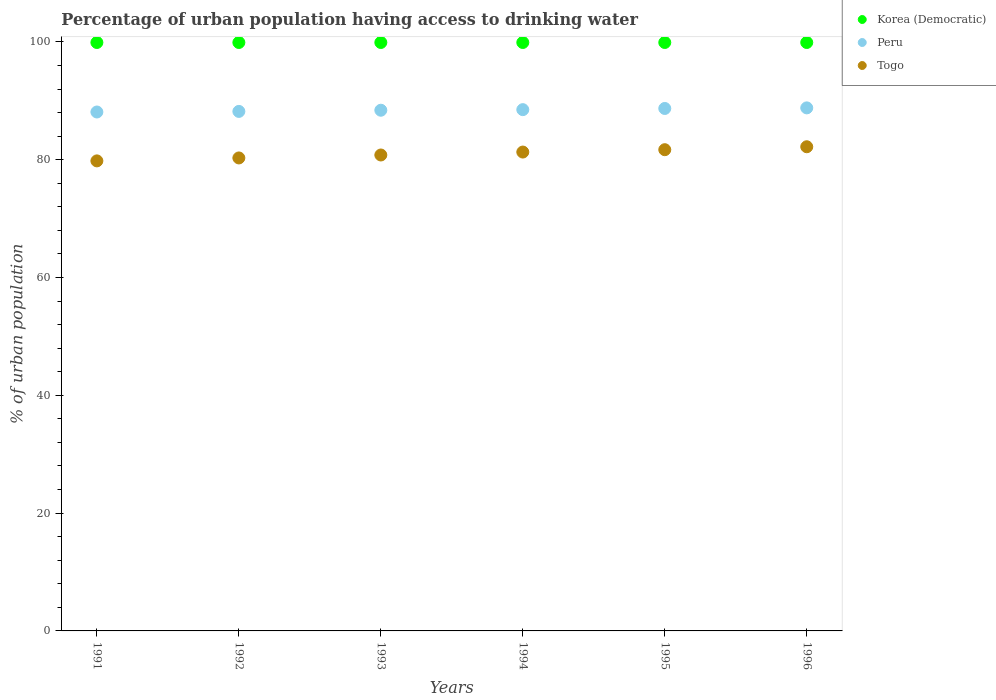Is the number of dotlines equal to the number of legend labels?
Make the answer very short. Yes. What is the percentage of urban population having access to drinking water in Peru in 1993?
Ensure brevity in your answer.  88.4. Across all years, what is the maximum percentage of urban population having access to drinking water in Peru?
Make the answer very short. 88.8. Across all years, what is the minimum percentage of urban population having access to drinking water in Peru?
Offer a very short reply. 88.1. In which year was the percentage of urban population having access to drinking water in Peru maximum?
Offer a terse response. 1996. In which year was the percentage of urban population having access to drinking water in Korea (Democratic) minimum?
Keep it short and to the point. 1991. What is the total percentage of urban population having access to drinking water in Peru in the graph?
Your response must be concise. 530.7. What is the difference between the percentage of urban population having access to drinking water in Togo in 1992 and that in 1995?
Your answer should be compact. -1.4. What is the difference between the percentage of urban population having access to drinking water in Peru in 1993 and the percentage of urban population having access to drinking water in Korea (Democratic) in 1992?
Provide a succinct answer. -11.5. What is the average percentage of urban population having access to drinking water in Korea (Democratic) per year?
Provide a succinct answer. 99.9. In the year 1993, what is the difference between the percentage of urban population having access to drinking water in Peru and percentage of urban population having access to drinking water in Togo?
Your answer should be very brief. 7.6. In how many years, is the percentage of urban population having access to drinking water in Korea (Democratic) greater than 92 %?
Offer a very short reply. 6. What is the ratio of the percentage of urban population having access to drinking water in Togo in 1991 to that in 1996?
Keep it short and to the point. 0.97. Is the percentage of urban population having access to drinking water in Togo in 1991 less than that in 1996?
Provide a succinct answer. Yes. What is the difference between the highest and the second highest percentage of urban population having access to drinking water in Peru?
Provide a succinct answer. 0.1. In how many years, is the percentage of urban population having access to drinking water in Peru greater than the average percentage of urban population having access to drinking water in Peru taken over all years?
Provide a short and direct response. 3. Is the sum of the percentage of urban population having access to drinking water in Korea (Democratic) in 1994 and 1996 greater than the maximum percentage of urban population having access to drinking water in Togo across all years?
Your answer should be very brief. Yes. Is it the case that in every year, the sum of the percentage of urban population having access to drinking water in Togo and percentage of urban population having access to drinking water in Korea (Democratic)  is greater than the percentage of urban population having access to drinking water in Peru?
Keep it short and to the point. Yes. Is the percentage of urban population having access to drinking water in Togo strictly greater than the percentage of urban population having access to drinking water in Korea (Democratic) over the years?
Provide a short and direct response. No. Is the percentage of urban population having access to drinking water in Korea (Democratic) strictly less than the percentage of urban population having access to drinking water in Togo over the years?
Ensure brevity in your answer.  No. How many dotlines are there?
Your answer should be very brief. 3. What is the difference between two consecutive major ticks on the Y-axis?
Make the answer very short. 20. Are the values on the major ticks of Y-axis written in scientific E-notation?
Keep it short and to the point. No. Does the graph contain any zero values?
Make the answer very short. No. Where does the legend appear in the graph?
Offer a terse response. Top right. How are the legend labels stacked?
Ensure brevity in your answer.  Vertical. What is the title of the graph?
Offer a very short reply. Percentage of urban population having access to drinking water. Does "St. Kitts and Nevis" appear as one of the legend labels in the graph?
Offer a very short reply. No. What is the label or title of the Y-axis?
Offer a very short reply. % of urban population. What is the % of urban population of Korea (Democratic) in 1991?
Provide a succinct answer. 99.9. What is the % of urban population in Peru in 1991?
Offer a terse response. 88.1. What is the % of urban population in Togo in 1991?
Provide a short and direct response. 79.8. What is the % of urban population of Korea (Democratic) in 1992?
Provide a succinct answer. 99.9. What is the % of urban population of Peru in 1992?
Keep it short and to the point. 88.2. What is the % of urban population of Togo in 1992?
Provide a short and direct response. 80.3. What is the % of urban population of Korea (Democratic) in 1993?
Provide a succinct answer. 99.9. What is the % of urban population of Peru in 1993?
Provide a short and direct response. 88.4. What is the % of urban population in Togo in 1993?
Offer a terse response. 80.8. What is the % of urban population in Korea (Democratic) in 1994?
Keep it short and to the point. 99.9. What is the % of urban population of Peru in 1994?
Your answer should be compact. 88.5. What is the % of urban population in Togo in 1994?
Your answer should be compact. 81.3. What is the % of urban population of Korea (Democratic) in 1995?
Ensure brevity in your answer.  99.9. What is the % of urban population in Peru in 1995?
Provide a succinct answer. 88.7. What is the % of urban population of Togo in 1995?
Give a very brief answer. 81.7. What is the % of urban population of Korea (Democratic) in 1996?
Provide a succinct answer. 99.9. What is the % of urban population in Peru in 1996?
Provide a short and direct response. 88.8. What is the % of urban population of Togo in 1996?
Make the answer very short. 82.2. Across all years, what is the maximum % of urban population in Korea (Democratic)?
Give a very brief answer. 99.9. Across all years, what is the maximum % of urban population of Peru?
Keep it short and to the point. 88.8. Across all years, what is the maximum % of urban population in Togo?
Give a very brief answer. 82.2. Across all years, what is the minimum % of urban population of Korea (Democratic)?
Your response must be concise. 99.9. Across all years, what is the minimum % of urban population of Peru?
Provide a succinct answer. 88.1. Across all years, what is the minimum % of urban population of Togo?
Give a very brief answer. 79.8. What is the total % of urban population in Korea (Democratic) in the graph?
Ensure brevity in your answer.  599.4. What is the total % of urban population in Peru in the graph?
Your answer should be compact. 530.7. What is the total % of urban population of Togo in the graph?
Your response must be concise. 486.1. What is the difference between the % of urban population in Togo in 1991 and that in 1992?
Your response must be concise. -0.5. What is the difference between the % of urban population in Korea (Democratic) in 1991 and that in 1993?
Provide a succinct answer. 0. What is the difference between the % of urban population in Korea (Democratic) in 1991 and that in 1994?
Provide a succinct answer. 0. What is the difference between the % of urban population in Peru in 1991 and that in 1994?
Your answer should be very brief. -0.4. What is the difference between the % of urban population of Peru in 1991 and that in 1995?
Offer a very short reply. -0.6. What is the difference between the % of urban population in Korea (Democratic) in 1991 and that in 1996?
Offer a terse response. 0. What is the difference between the % of urban population of Peru in 1991 and that in 1996?
Offer a very short reply. -0.7. What is the difference between the % of urban population in Togo in 1991 and that in 1996?
Your answer should be compact. -2.4. What is the difference between the % of urban population in Peru in 1992 and that in 1993?
Make the answer very short. -0.2. What is the difference between the % of urban population in Togo in 1992 and that in 1993?
Give a very brief answer. -0.5. What is the difference between the % of urban population in Korea (Democratic) in 1992 and that in 1994?
Ensure brevity in your answer.  0. What is the difference between the % of urban population of Korea (Democratic) in 1992 and that in 1995?
Offer a very short reply. 0. What is the difference between the % of urban population in Peru in 1992 and that in 1995?
Your answer should be very brief. -0.5. What is the difference between the % of urban population in Togo in 1992 and that in 1995?
Ensure brevity in your answer.  -1.4. What is the difference between the % of urban population of Peru in 1992 and that in 1996?
Your answer should be compact. -0.6. What is the difference between the % of urban population in Togo in 1992 and that in 1996?
Your answer should be very brief. -1.9. What is the difference between the % of urban population in Togo in 1993 and that in 1994?
Offer a terse response. -0.5. What is the difference between the % of urban population in Korea (Democratic) in 1993 and that in 1995?
Your answer should be compact. 0. What is the difference between the % of urban population of Togo in 1993 and that in 1995?
Your response must be concise. -0.9. What is the difference between the % of urban population of Korea (Democratic) in 1994 and that in 1995?
Keep it short and to the point. 0. What is the difference between the % of urban population in Togo in 1994 and that in 1995?
Ensure brevity in your answer.  -0.4. What is the difference between the % of urban population of Korea (Democratic) in 1994 and that in 1996?
Make the answer very short. 0. What is the difference between the % of urban population in Peru in 1994 and that in 1996?
Offer a very short reply. -0.3. What is the difference between the % of urban population of Korea (Democratic) in 1995 and that in 1996?
Offer a very short reply. 0. What is the difference between the % of urban population in Togo in 1995 and that in 1996?
Your response must be concise. -0.5. What is the difference between the % of urban population in Korea (Democratic) in 1991 and the % of urban population in Togo in 1992?
Your answer should be very brief. 19.6. What is the difference between the % of urban population of Peru in 1991 and the % of urban population of Togo in 1992?
Provide a succinct answer. 7.8. What is the difference between the % of urban population in Korea (Democratic) in 1991 and the % of urban population in Togo in 1993?
Your response must be concise. 19.1. What is the difference between the % of urban population of Korea (Democratic) in 1991 and the % of urban population of Togo in 1994?
Your answer should be very brief. 18.6. What is the difference between the % of urban population in Korea (Democratic) in 1991 and the % of urban population in Peru in 1995?
Offer a terse response. 11.2. What is the difference between the % of urban population in Korea (Democratic) in 1991 and the % of urban population in Peru in 1996?
Make the answer very short. 11.1. What is the difference between the % of urban population of Peru in 1991 and the % of urban population of Togo in 1996?
Ensure brevity in your answer.  5.9. What is the difference between the % of urban population in Korea (Democratic) in 1992 and the % of urban population in Togo in 1994?
Keep it short and to the point. 18.6. What is the difference between the % of urban population in Peru in 1992 and the % of urban population in Togo in 1994?
Make the answer very short. 6.9. What is the difference between the % of urban population in Korea (Democratic) in 1992 and the % of urban population in Togo in 1995?
Ensure brevity in your answer.  18.2. What is the difference between the % of urban population of Peru in 1992 and the % of urban population of Togo in 1995?
Provide a short and direct response. 6.5. What is the difference between the % of urban population in Korea (Democratic) in 1992 and the % of urban population in Peru in 1996?
Provide a short and direct response. 11.1. What is the difference between the % of urban population of Korea (Democratic) in 1992 and the % of urban population of Togo in 1996?
Provide a short and direct response. 17.7. What is the difference between the % of urban population in Korea (Democratic) in 1993 and the % of urban population in Togo in 1994?
Your answer should be very brief. 18.6. What is the difference between the % of urban population in Korea (Democratic) in 1993 and the % of urban population in Peru in 1995?
Provide a succinct answer. 11.2. What is the difference between the % of urban population of Korea (Democratic) in 1993 and the % of urban population of Togo in 1995?
Keep it short and to the point. 18.2. What is the difference between the % of urban population of Korea (Democratic) in 1993 and the % of urban population of Peru in 1996?
Ensure brevity in your answer.  11.1. What is the difference between the % of urban population in Korea (Democratic) in 1993 and the % of urban population in Togo in 1996?
Offer a very short reply. 17.7. What is the difference between the % of urban population in Peru in 1993 and the % of urban population in Togo in 1996?
Make the answer very short. 6.2. What is the difference between the % of urban population in Korea (Democratic) in 1994 and the % of urban population in Peru in 1995?
Offer a terse response. 11.2. What is the difference between the % of urban population of Peru in 1994 and the % of urban population of Togo in 1995?
Provide a succinct answer. 6.8. What is the difference between the % of urban population in Korea (Democratic) in 1994 and the % of urban population in Peru in 1996?
Provide a short and direct response. 11.1. What is the difference between the % of urban population in Korea (Democratic) in 1995 and the % of urban population in Togo in 1996?
Keep it short and to the point. 17.7. What is the average % of urban population in Korea (Democratic) per year?
Your answer should be very brief. 99.9. What is the average % of urban population in Peru per year?
Keep it short and to the point. 88.45. What is the average % of urban population in Togo per year?
Offer a very short reply. 81.02. In the year 1991, what is the difference between the % of urban population of Korea (Democratic) and % of urban population of Togo?
Keep it short and to the point. 20.1. In the year 1992, what is the difference between the % of urban population of Korea (Democratic) and % of urban population of Togo?
Your answer should be very brief. 19.6. In the year 1992, what is the difference between the % of urban population of Peru and % of urban population of Togo?
Your answer should be very brief. 7.9. In the year 1993, what is the difference between the % of urban population of Korea (Democratic) and % of urban population of Togo?
Your answer should be compact. 19.1. In the year 1993, what is the difference between the % of urban population of Peru and % of urban population of Togo?
Your answer should be compact. 7.6. In the year 1994, what is the difference between the % of urban population of Korea (Democratic) and % of urban population of Peru?
Ensure brevity in your answer.  11.4. In the year 1994, what is the difference between the % of urban population of Korea (Democratic) and % of urban population of Togo?
Keep it short and to the point. 18.6. In the year 1995, what is the difference between the % of urban population of Korea (Democratic) and % of urban population of Togo?
Your answer should be compact. 18.2. In the year 1996, what is the difference between the % of urban population of Korea (Democratic) and % of urban population of Peru?
Offer a very short reply. 11.1. In the year 1996, what is the difference between the % of urban population in Korea (Democratic) and % of urban population in Togo?
Your answer should be very brief. 17.7. What is the ratio of the % of urban population in Korea (Democratic) in 1991 to that in 1992?
Keep it short and to the point. 1. What is the ratio of the % of urban population in Peru in 1991 to that in 1992?
Give a very brief answer. 1. What is the ratio of the % of urban population in Togo in 1991 to that in 1993?
Give a very brief answer. 0.99. What is the ratio of the % of urban population in Peru in 1991 to that in 1994?
Your response must be concise. 1. What is the ratio of the % of urban population of Togo in 1991 to that in 1994?
Ensure brevity in your answer.  0.98. What is the ratio of the % of urban population of Peru in 1991 to that in 1995?
Your response must be concise. 0.99. What is the ratio of the % of urban population in Togo in 1991 to that in 1995?
Your answer should be compact. 0.98. What is the ratio of the % of urban population in Korea (Democratic) in 1991 to that in 1996?
Provide a short and direct response. 1. What is the ratio of the % of urban population in Togo in 1991 to that in 1996?
Keep it short and to the point. 0.97. What is the ratio of the % of urban population in Togo in 1992 to that in 1994?
Provide a succinct answer. 0.99. What is the ratio of the % of urban population of Peru in 1992 to that in 1995?
Your response must be concise. 0.99. What is the ratio of the % of urban population of Togo in 1992 to that in 1995?
Your answer should be very brief. 0.98. What is the ratio of the % of urban population of Togo in 1992 to that in 1996?
Your answer should be compact. 0.98. What is the ratio of the % of urban population in Korea (Democratic) in 1993 to that in 1994?
Your answer should be compact. 1. What is the ratio of the % of urban population of Peru in 1993 to that in 1994?
Your answer should be compact. 1. What is the ratio of the % of urban population of Korea (Democratic) in 1993 to that in 1995?
Keep it short and to the point. 1. What is the ratio of the % of urban population of Peru in 1993 to that in 1995?
Your answer should be compact. 1. What is the ratio of the % of urban population in Korea (Democratic) in 1993 to that in 1996?
Give a very brief answer. 1. What is the ratio of the % of urban population of Togo in 1993 to that in 1996?
Your answer should be very brief. 0.98. What is the ratio of the % of urban population in Togo in 1994 to that in 1995?
Give a very brief answer. 1. What is the ratio of the % of urban population of Peru in 1995 to that in 1996?
Offer a terse response. 1. What is the ratio of the % of urban population of Togo in 1995 to that in 1996?
Offer a very short reply. 0.99. What is the difference between the highest and the second highest % of urban population of Korea (Democratic)?
Provide a succinct answer. 0. What is the difference between the highest and the second highest % of urban population of Togo?
Provide a succinct answer. 0.5. What is the difference between the highest and the lowest % of urban population of Korea (Democratic)?
Offer a terse response. 0. What is the difference between the highest and the lowest % of urban population in Peru?
Your answer should be very brief. 0.7. 